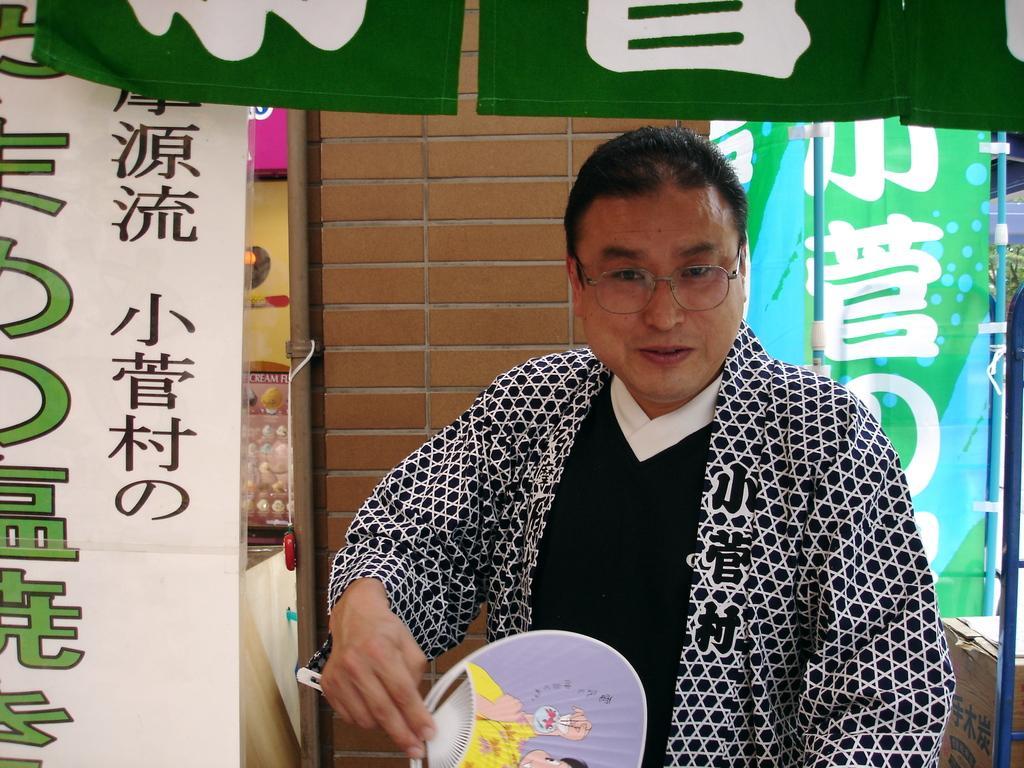Could you give a brief overview of what you see in this image? In this picture we can see a man wore spectacles, holding a hand fan with his hand and smiling. In the background we can see the wall, banners, poles and some objects. 